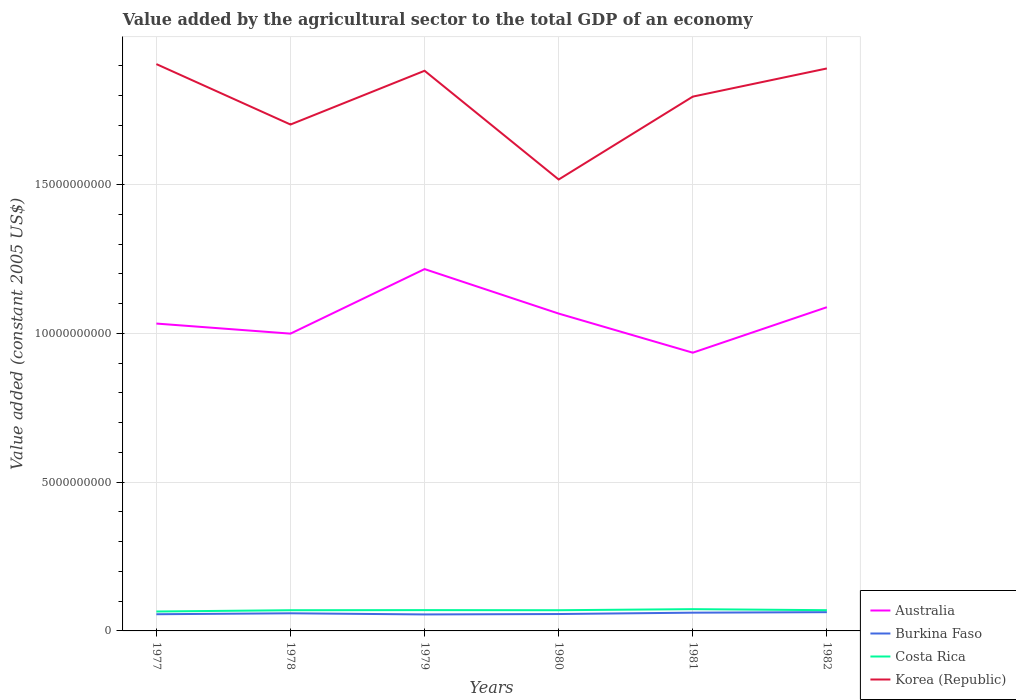Does the line corresponding to Korea (Republic) intersect with the line corresponding to Australia?
Keep it short and to the point. No. Across all years, what is the maximum value added by the agricultural sector in Korea (Republic)?
Give a very brief answer. 1.52e+1. In which year was the value added by the agricultural sector in Burkina Faso maximum?
Your response must be concise. 1979. What is the total value added by the agricultural sector in Costa Rica in the graph?
Your answer should be very brief. -3.55e+07. What is the difference between the highest and the second highest value added by the agricultural sector in Korea (Republic)?
Offer a terse response. 3.88e+09. Is the value added by the agricultural sector in Costa Rica strictly greater than the value added by the agricultural sector in Australia over the years?
Provide a short and direct response. Yes. How many lines are there?
Provide a succinct answer. 4. How many years are there in the graph?
Offer a very short reply. 6. Does the graph contain grids?
Make the answer very short. Yes. How many legend labels are there?
Provide a succinct answer. 4. How are the legend labels stacked?
Keep it short and to the point. Vertical. What is the title of the graph?
Offer a terse response. Value added by the agricultural sector to the total GDP of an economy. What is the label or title of the Y-axis?
Provide a succinct answer. Value added (constant 2005 US$). What is the Value added (constant 2005 US$) in Australia in 1977?
Give a very brief answer. 1.03e+1. What is the Value added (constant 2005 US$) in Burkina Faso in 1977?
Make the answer very short. 5.61e+08. What is the Value added (constant 2005 US$) of Costa Rica in 1977?
Your response must be concise. 6.53e+08. What is the Value added (constant 2005 US$) in Korea (Republic) in 1977?
Make the answer very short. 1.91e+1. What is the Value added (constant 2005 US$) in Australia in 1978?
Provide a short and direct response. 9.99e+09. What is the Value added (constant 2005 US$) of Burkina Faso in 1978?
Provide a short and direct response. 5.92e+08. What is the Value added (constant 2005 US$) of Costa Rica in 1978?
Provide a short and direct response. 6.96e+08. What is the Value added (constant 2005 US$) of Korea (Republic) in 1978?
Your answer should be compact. 1.70e+1. What is the Value added (constant 2005 US$) in Australia in 1979?
Keep it short and to the point. 1.22e+1. What is the Value added (constant 2005 US$) in Burkina Faso in 1979?
Give a very brief answer. 5.54e+08. What is the Value added (constant 2005 US$) in Costa Rica in 1979?
Ensure brevity in your answer.  7.00e+08. What is the Value added (constant 2005 US$) of Korea (Republic) in 1979?
Give a very brief answer. 1.88e+1. What is the Value added (constant 2005 US$) in Australia in 1980?
Offer a very short reply. 1.07e+1. What is the Value added (constant 2005 US$) in Burkina Faso in 1980?
Your answer should be compact. 5.68e+08. What is the Value added (constant 2005 US$) in Costa Rica in 1980?
Keep it short and to the point. 6.96e+08. What is the Value added (constant 2005 US$) in Korea (Republic) in 1980?
Make the answer very short. 1.52e+1. What is the Value added (constant 2005 US$) in Australia in 1981?
Give a very brief answer. 9.35e+09. What is the Value added (constant 2005 US$) of Burkina Faso in 1981?
Your answer should be compact. 6.14e+08. What is the Value added (constant 2005 US$) of Costa Rica in 1981?
Provide a succinct answer. 7.32e+08. What is the Value added (constant 2005 US$) in Korea (Republic) in 1981?
Give a very brief answer. 1.80e+1. What is the Value added (constant 2005 US$) of Australia in 1982?
Ensure brevity in your answer.  1.09e+1. What is the Value added (constant 2005 US$) in Burkina Faso in 1982?
Offer a very short reply. 6.31e+08. What is the Value added (constant 2005 US$) in Costa Rica in 1982?
Keep it short and to the point. 6.97e+08. What is the Value added (constant 2005 US$) of Korea (Republic) in 1982?
Ensure brevity in your answer.  1.89e+1. Across all years, what is the maximum Value added (constant 2005 US$) of Australia?
Offer a terse response. 1.22e+1. Across all years, what is the maximum Value added (constant 2005 US$) in Burkina Faso?
Provide a short and direct response. 6.31e+08. Across all years, what is the maximum Value added (constant 2005 US$) of Costa Rica?
Provide a short and direct response. 7.32e+08. Across all years, what is the maximum Value added (constant 2005 US$) of Korea (Republic)?
Ensure brevity in your answer.  1.91e+1. Across all years, what is the minimum Value added (constant 2005 US$) of Australia?
Keep it short and to the point. 9.35e+09. Across all years, what is the minimum Value added (constant 2005 US$) in Burkina Faso?
Your response must be concise. 5.54e+08. Across all years, what is the minimum Value added (constant 2005 US$) of Costa Rica?
Keep it short and to the point. 6.53e+08. Across all years, what is the minimum Value added (constant 2005 US$) in Korea (Republic)?
Offer a very short reply. 1.52e+1. What is the total Value added (constant 2005 US$) of Australia in the graph?
Ensure brevity in your answer.  6.34e+1. What is the total Value added (constant 2005 US$) of Burkina Faso in the graph?
Ensure brevity in your answer.  3.52e+09. What is the total Value added (constant 2005 US$) in Costa Rica in the graph?
Provide a succinct answer. 4.17e+09. What is the total Value added (constant 2005 US$) of Korea (Republic) in the graph?
Give a very brief answer. 1.07e+11. What is the difference between the Value added (constant 2005 US$) in Australia in 1977 and that in 1978?
Keep it short and to the point. 3.39e+08. What is the difference between the Value added (constant 2005 US$) in Burkina Faso in 1977 and that in 1978?
Your answer should be very brief. -3.14e+07. What is the difference between the Value added (constant 2005 US$) in Costa Rica in 1977 and that in 1978?
Your response must be concise. -4.31e+07. What is the difference between the Value added (constant 2005 US$) of Korea (Republic) in 1977 and that in 1978?
Make the answer very short. 2.03e+09. What is the difference between the Value added (constant 2005 US$) in Australia in 1977 and that in 1979?
Offer a terse response. -1.83e+09. What is the difference between the Value added (constant 2005 US$) of Burkina Faso in 1977 and that in 1979?
Make the answer very short. 6.73e+06. What is the difference between the Value added (constant 2005 US$) of Costa Rica in 1977 and that in 1979?
Provide a short and direct response. -4.66e+07. What is the difference between the Value added (constant 2005 US$) of Korea (Republic) in 1977 and that in 1979?
Offer a terse response. 2.25e+08. What is the difference between the Value added (constant 2005 US$) of Australia in 1977 and that in 1980?
Provide a short and direct response. -3.35e+08. What is the difference between the Value added (constant 2005 US$) in Burkina Faso in 1977 and that in 1980?
Your answer should be very brief. -6.97e+06. What is the difference between the Value added (constant 2005 US$) of Costa Rica in 1977 and that in 1980?
Your answer should be compact. -4.31e+07. What is the difference between the Value added (constant 2005 US$) in Korea (Republic) in 1977 and that in 1980?
Offer a very short reply. 3.88e+09. What is the difference between the Value added (constant 2005 US$) of Australia in 1977 and that in 1981?
Your response must be concise. 9.80e+08. What is the difference between the Value added (constant 2005 US$) of Burkina Faso in 1977 and that in 1981?
Keep it short and to the point. -5.28e+07. What is the difference between the Value added (constant 2005 US$) in Costa Rica in 1977 and that in 1981?
Your answer should be very brief. -7.85e+07. What is the difference between the Value added (constant 2005 US$) in Korea (Republic) in 1977 and that in 1981?
Provide a succinct answer. 1.09e+09. What is the difference between the Value added (constant 2005 US$) in Australia in 1977 and that in 1982?
Your response must be concise. -5.50e+08. What is the difference between the Value added (constant 2005 US$) in Burkina Faso in 1977 and that in 1982?
Offer a terse response. -6.99e+07. What is the difference between the Value added (constant 2005 US$) of Costa Rica in 1977 and that in 1982?
Your answer should be very brief. -4.41e+07. What is the difference between the Value added (constant 2005 US$) of Korea (Republic) in 1977 and that in 1982?
Your answer should be compact. 1.47e+08. What is the difference between the Value added (constant 2005 US$) in Australia in 1978 and that in 1979?
Offer a terse response. -2.17e+09. What is the difference between the Value added (constant 2005 US$) of Burkina Faso in 1978 and that in 1979?
Your answer should be compact. 3.82e+07. What is the difference between the Value added (constant 2005 US$) in Costa Rica in 1978 and that in 1979?
Provide a succinct answer. -3.45e+06. What is the difference between the Value added (constant 2005 US$) of Korea (Republic) in 1978 and that in 1979?
Offer a terse response. -1.81e+09. What is the difference between the Value added (constant 2005 US$) of Australia in 1978 and that in 1980?
Give a very brief answer. -6.74e+08. What is the difference between the Value added (constant 2005 US$) in Burkina Faso in 1978 and that in 1980?
Ensure brevity in your answer.  2.45e+07. What is the difference between the Value added (constant 2005 US$) in Costa Rica in 1978 and that in 1980?
Offer a terse response. 4.01e+04. What is the difference between the Value added (constant 2005 US$) of Korea (Republic) in 1978 and that in 1980?
Give a very brief answer. 1.85e+09. What is the difference between the Value added (constant 2005 US$) of Australia in 1978 and that in 1981?
Keep it short and to the point. 6.41e+08. What is the difference between the Value added (constant 2005 US$) of Burkina Faso in 1978 and that in 1981?
Ensure brevity in your answer.  -2.14e+07. What is the difference between the Value added (constant 2005 US$) in Costa Rica in 1978 and that in 1981?
Provide a short and direct response. -3.54e+07. What is the difference between the Value added (constant 2005 US$) of Korea (Republic) in 1978 and that in 1981?
Your answer should be very brief. -9.38e+08. What is the difference between the Value added (constant 2005 US$) of Australia in 1978 and that in 1982?
Make the answer very short. -8.89e+08. What is the difference between the Value added (constant 2005 US$) of Burkina Faso in 1978 and that in 1982?
Provide a succinct answer. -3.85e+07. What is the difference between the Value added (constant 2005 US$) in Costa Rica in 1978 and that in 1982?
Your answer should be very brief. -1.04e+06. What is the difference between the Value added (constant 2005 US$) of Korea (Republic) in 1978 and that in 1982?
Provide a short and direct response. -1.89e+09. What is the difference between the Value added (constant 2005 US$) in Australia in 1979 and that in 1980?
Provide a succinct answer. 1.50e+09. What is the difference between the Value added (constant 2005 US$) of Burkina Faso in 1979 and that in 1980?
Make the answer very short. -1.37e+07. What is the difference between the Value added (constant 2005 US$) of Costa Rica in 1979 and that in 1980?
Your response must be concise. 3.49e+06. What is the difference between the Value added (constant 2005 US$) of Korea (Republic) in 1979 and that in 1980?
Give a very brief answer. 3.66e+09. What is the difference between the Value added (constant 2005 US$) in Australia in 1979 and that in 1981?
Your answer should be compact. 2.81e+09. What is the difference between the Value added (constant 2005 US$) of Burkina Faso in 1979 and that in 1981?
Give a very brief answer. -5.96e+07. What is the difference between the Value added (constant 2005 US$) in Costa Rica in 1979 and that in 1981?
Your answer should be very brief. -3.20e+07. What is the difference between the Value added (constant 2005 US$) in Korea (Republic) in 1979 and that in 1981?
Offer a terse response. 8.69e+08. What is the difference between the Value added (constant 2005 US$) of Australia in 1979 and that in 1982?
Ensure brevity in your answer.  1.28e+09. What is the difference between the Value added (constant 2005 US$) of Burkina Faso in 1979 and that in 1982?
Your answer should be very brief. -7.67e+07. What is the difference between the Value added (constant 2005 US$) of Costa Rica in 1979 and that in 1982?
Make the answer very short. 2.41e+06. What is the difference between the Value added (constant 2005 US$) of Korea (Republic) in 1979 and that in 1982?
Provide a succinct answer. -7.82e+07. What is the difference between the Value added (constant 2005 US$) of Australia in 1980 and that in 1981?
Give a very brief answer. 1.32e+09. What is the difference between the Value added (constant 2005 US$) in Burkina Faso in 1980 and that in 1981?
Give a very brief answer. -4.59e+07. What is the difference between the Value added (constant 2005 US$) in Costa Rica in 1980 and that in 1981?
Make the answer very short. -3.55e+07. What is the difference between the Value added (constant 2005 US$) in Korea (Republic) in 1980 and that in 1981?
Your answer should be compact. -2.79e+09. What is the difference between the Value added (constant 2005 US$) in Australia in 1980 and that in 1982?
Your response must be concise. -2.15e+08. What is the difference between the Value added (constant 2005 US$) in Burkina Faso in 1980 and that in 1982?
Give a very brief answer. -6.30e+07. What is the difference between the Value added (constant 2005 US$) of Costa Rica in 1980 and that in 1982?
Your answer should be compact. -1.08e+06. What is the difference between the Value added (constant 2005 US$) in Korea (Republic) in 1980 and that in 1982?
Offer a terse response. -3.73e+09. What is the difference between the Value added (constant 2005 US$) in Australia in 1981 and that in 1982?
Provide a succinct answer. -1.53e+09. What is the difference between the Value added (constant 2005 US$) of Burkina Faso in 1981 and that in 1982?
Keep it short and to the point. -1.71e+07. What is the difference between the Value added (constant 2005 US$) in Costa Rica in 1981 and that in 1982?
Your answer should be very brief. 3.44e+07. What is the difference between the Value added (constant 2005 US$) in Korea (Republic) in 1981 and that in 1982?
Your answer should be compact. -9.47e+08. What is the difference between the Value added (constant 2005 US$) in Australia in 1977 and the Value added (constant 2005 US$) in Burkina Faso in 1978?
Offer a terse response. 9.74e+09. What is the difference between the Value added (constant 2005 US$) in Australia in 1977 and the Value added (constant 2005 US$) in Costa Rica in 1978?
Your answer should be compact. 9.64e+09. What is the difference between the Value added (constant 2005 US$) in Australia in 1977 and the Value added (constant 2005 US$) in Korea (Republic) in 1978?
Your answer should be very brief. -6.69e+09. What is the difference between the Value added (constant 2005 US$) of Burkina Faso in 1977 and the Value added (constant 2005 US$) of Costa Rica in 1978?
Provide a succinct answer. -1.35e+08. What is the difference between the Value added (constant 2005 US$) of Burkina Faso in 1977 and the Value added (constant 2005 US$) of Korea (Republic) in 1978?
Provide a succinct answer. -1.65e+1. What is the difference between the Value added (constant 2005 US$) in Costa Rica in 1977 and the Value added (constant 2005 US$) in Korea (Republic) in 1978?
Offer a terse response. -1.64e+1. What is the difference between the Value added (constant 2005 US$) of Australia in 1977 and the Value added (constant 2005 US$) of Burkina Faso in 1979?
Ensure brevity in your answer.  9.78e+09. What is the difference between the Value added (constant 2005 US$) in Australia in 1977 and the Value added (constant 2005 US$) in Costa Rica in 1979?
Your answer should be very brief. 9.63e+09. What is the difference between the Value added (constant 2005 US$) in Australia in 1977 and the Value added (constant 2005 US$) in Korea (Republic) in 1979?
Keep it short and to the point. -8.50e+09. What is the difference between the Value added (constant 2005 US$) of Burkina Faso in 1977 and the Value added (constant 2005 US$) of Costa Rica in 1979?
Ensure brevity in your answer.  -1.39e+08. What is the difference between the Value added (constant 2005 US$) of Burkina Faso in 1977 and the Value added (constant 2005 US$) of Korea (Republic) in 1979?
Give a very brief answer. -1.83e+1. What is the difference between the Value added (constant 2005 US$) in Costa Rica in 1977 and the Value added (constant 2005 US$) in Korea (Republic) in 1979?
Make the answer very short. -1.82e+1. What is the difference between the Value added (constant 2005 US$) of Australia in 1977 and the Value added (constant 2005 US$) of Burkina Faso in 1980?
Offer a terse response. 9.77e+09. What is the difference between the Value added (constant 2005 US$) of Australia in 1977 and the Value added (constant 2005 US$) of Costa Rica in 1980?
Offer a very short reply. 9.64e+09. What is the difference between the Value added (constant 2005 US$) in Australia in 1977 and the Value added (constant 2005 US$) in Korea (Republic) in 1980?
Your answer should be very brief. -4.84e+09. What is the difference between the Value added (constant 2005 US$) in Burkina Faso in 1977 and the Value added (constant 2005 US$) in Costa Rica in 1980?
Provide a short and direct response. -1.35e+08. What is the difference between the Value added (constant 2005 US$) in Burkina Faso in 1977 and the Value added (constant 2005 US$) in Korea (Republic) in 1980?
Your response must be concise. -1.46e+1. What is the difference between the Value added (constant 2005 US$) of Costa Rica in 1977 and the Value added (constant 2005 US$) of Korea (Republic) in 1980?
Offer a terse response. -1.45e+1. What is the difference between the Value added (constant 2005 US$) of Australia in 1977 and the Value added (constant 2005 US$) of Burkina Faso in 1981?
Provide a succinct answer. 9.72e+09. What is the difference between the Value added (constant 2005 US$) in Australia in 1977 and the Value added (constant 2005 US$) in Costa Rica in 1981?
Make the answer very short. 9.60e+09. What is the difference between the Value added (constant 2005 US$) of Australia in 1977 and the Value added (constant 2005 US$) of Korea (Republic) in 1981?
Give a very brief answer. -7.63e+09. What is the difference between the Value added (constant 2005 US$) of Burkina Faso in 1977 and the Value added (constant 2005 US$) of Costa Rica in 1981?
Give a very brief answer. -1.71e+08. What is the difference between the Value added (constant 2005 US$) in Burkina Faso in 1977 and the Value added (constant 2005 US$) in Korea (Republic) in 1981?
Keep it short and to the point. -1.74e+1. What is the difference between the Value added (constant 2005 US$) of Costa Rica in 1977 and the Value added (constant 2005 US$) of Korea (Republic) in 1981?
Offer a terse response. -1.73e+1. What is the difference between the Value added (constant 2005 US$) in Australia in 1977 and the Value added (constant 2005 US$) in Burkina Faso in 1982?
Keep it short and to the point. 9.70e+09. What is the difference between the Value added (constant 2005 US$) in Australia in 1977 and the Value added (constant 2005 US$) in Costa Rica in 1982?
Ensure brevity in your answer.  9.64e+09. What is the difference between the Value added (constant 2005 US$) of Australia in 1977 and the Value added (constant 2005 US$) of Korea (Republic) in 1982?
Offer a terse response. -8.58e+09. What is the difference between the Value added (constant 2005 US$) of Burkina Faso in 1977 and the Value added (constant 2005 US$) of Costa Rica in 1982?
Offer a very short reply. -1.36e+08. What is the difference between the Value added (constant 2005 US$) in Burkina Faso in 1977 and the Value added (constant 2005 US$) in Korea (Republic) in 1982?
Offer a terse response. -1.83e+1. What is the difference between the Value added (constant 2005 US$) in Costa Rica in 1977 and the Value added (constant 2005 US$) in Korea (Republic) in 1982?
Provide a succinct answer. -1.83e+1. What is the difference between the Value added (constant 2005 US$) of Australia in 1978 and the Value added (constant 2005 US$) of Burkina Faso in 1979?
Your response must be concise. 9.44e+09. What is the difference between the Value added (constant 2005 US$) in Australia in 1978 and the Value added (constant 2005 US$) in Costa Rica in 1979?
Keep it short and to the point. 9.30e+09. What is the difference between the Value added (constant 2005 US$) of Australia in 1978 and the Value added (constant 2005 US$) of Korea (Republic) in 1979?
Keep it short and to the point. -8.84e+09. What is the difference between the Value added (constant 2005 US$) in Burkina Faso in 1978 and the Value added (constant 2005 US$) in Costa Rica in 1979?
Give a very brief answer. -1.07e+08. What is the difference between the Value added (constant 2005 US$) in Burkina Faso in 1978 and the Value added (constant 2005 US$) in Korea (Republic) in 1979?
Provide a short and direct response. -1.82e+1. What is the difference between the Value added (constant 2005 US$) in Costa Rica in 1978 and the Value added (constant 2005 US$) in Korea (Republic) in 1979?
Your answer should be compact. -1.81e+1. What is the difference between the Value added (constant 2005 US$) of Australia in 1978 and the Value added (constant 2005 US$) of Burkina Faso in 1980?
Give a very brief answer. 9.43e+09. What is the difference between the Value added (constant 2005 US$) in Australia in 1978 and the Value added (constant 2005 US$) in Costa Rica in 1980?
Your response must be concise. 9.30e+09. What is the difference between the Value added (constant 2005 US$) of Australia in 1978 and the Value added (constant 2005 US$) of Korea (Republic) in 1980?
Your answer should be compact. -5.18e+09. What is the difference between the Value added (constant 2005 US$) of Burkina Faso in 1978 and the Value added (constant 2005 US$) of Costa Rica in 1980?
Offer a terse response. -1.04e+08. What is the difference between the Value added (constant 2005 US$) in Burkina Faso in 1978 and the Value added (constant 2005 US$) in Korea (Republic) in 1980?
Your answer should be compact. -1.46e+1. What is the difference between the Value added (constant 2005 US$) in Costa Rica in 1978 and the Value added (constant 2005 US$) in Korea (Republic) in 1980?
Your response must be concise. -1.45e+1. What is the difference between the Value added (constant 2005 US$) of Australia in 1978 and the Value added (constant 2005 US$) of Burkina Faso in 1981?
Offer a very short reply. 9.38e+09. What is the difference between the Value added (constant 2005 US$) of Australia in 1978 and the Value added (constant 2005 US$) of Costa Rica in 1981?
Keep it short and to the point. 9.26e+09. What is the difference between the Value added (constant 2005 US$) in Australia in 1978 and the Value added (constant 2005 US$) in Korea (Republic) in 1981?
Provide a succinct answer. -7.97e+09. What is the difference between the Value added (constant 2005 US$) in Burkina Faso in 1978 and the Value added (constant 2005 US$) in Costa Rica in 1981?
Ensure brevity in your answer.  -1.39e+08. What is the difference between the Value added (constant 2005 US$) in Burkina Faso in 1978 and the Value added (constant 2005 US$) in Korea (Republic) in 1981?
Give a very brief answer. -1.74e+1. What is the difference between the Value added (constant 2005 US$) of Costa Rica in 1978 and the Value added (constant 2005 US$) of Korea (Republic) in 1981?
Offer a terse response. -1.73e+1. What is the difference between the Value added (constant 2005 US$) in Australia in 1978 and the Value added (constant 2005 US$) in Burkina Faso in 1982?
Give a very brief answer. 9.36e+09. What is the difference between the Value added (constant 2005 US$) of Australia in 1978 and the Value added (constant 2005 US$) of Costa Rica in 1982?
Your response must be concise. 9.30e+09. What is the difference between the Value added (constant 2005 US$) of Australia in 1978 and the Value added (constant 2005 US$) of Korea (Republic) in 1982?
Keep it short and to the point. -8.92e+09. What is the difference between the Value added (constant 2005 US$) of Burkina Faso in 1978 and the Value added (constant 2005 US$) of Costa Rica in 1982?
Provide a short and direct response. -1.05e+08. What is the difference between the Value added (constant 2005 US$) in Burkina Faso in 1978 and the Value added (constant 2005 US$) in Korea (Republic) in 1982?
Your answer should be very brief. -1.83e+1. What is the difference between the Value added (constant 2005 US$) in Costa Rica in 1978 and the Value added (constant 2005 US$) in Korea (Republic) in 1982?
Ensure brevity in your answer.  -1.82e+1. What is the difference between the Value added (constant 2005 US$) of Australia in 1979 and the Value added (constant 2005 US$) of Burkina Faso in 1980?
Ensure brevity in your answer.  1.16e+1. What is the difference between the Value added (constant 2005 US$) in Australia in 1979 and the Value added (constant 2005 US$) in Costa Rica in 1980?
Provide a succinct answer. 1.15e+1. What is the difference between the Value added (constant 2005 US$) of Australia in 1979 and the Value added (constant 2005 US$) of Korea (Republic) in 1980?
Your response must be concise. -3.01e+09. What is the difference between the Value added (constant 2005 US$) of Burkina Faso in 1979 and the Value added (constant 2005 US$) of Costa Rica in 1980?
Keep it short and to the point. -1.42e+08. What is the difference between the Value added (constant 2005 US$) in Burkina Faso in 1979 and the Value added (constant 2005 US$) in Korea (Republic) in 1980?
Provide a short and direct response. -1.46e+1. What is the difference between the Value added (constant 2005 US$) of Costa Rica in 1979 and the Value added (constant 2005 US$) of Korea (Republic) in 1980?
Offer a very short reply. -1.45e+1. What is the difference between the Value added (constant 2005 US$) of Australia in 1979 and the Value added (constant 2005 US$) of Burkina Faso in 1981?
Provide a short and direct response. 1.16e+1. What is the difference between the Value added (constant 2005 US$) in Australia in 1979 and the Value added (constant 2005 US$) in Costa Rica in 1981?
Your response must be concise. 1.14e+1. What is the difference between the Value added (constant 2005 US$) in Australia in 1979 and the Value added (constant 2005 US$) in Korea (Republic) in 1981?
Your response must be concise. -5.80e+09. What is the difference between the Value added (constant 2005 US$) of Burkina Faso in 1979 and the Value added (constant 2005 US$) of Costa Rica in 1981?
Your answer should be very brief. -1.77e+08. What is the difference between the Value added (constant 2005 US$) of Burkina Faso in 1979 and the Value added (constant 2005 US$) of Korea (Republic) in 1981?
Your answer should be very brief. -1.74e+1. What is the difference between the Value added (constant 2005 US$) in Costa Rica in 1979 and the Value added (constant 2005 US$) in Korea (Republic) in 1981?
Your answer should be very brief. -1.73e+1. What is the difference between the Value added (constant 2005 US$) in Australia in 1979 and the Value added (constant 2005 US$) in Burkina Faso in 1982?
Offer a very short reply. 1.15e+1. What is the difference between the Value added (constant 2005 US$) in Australia in 1979 and the Value added (constant 2005 US$) in Costa Rica in 1982?
Keep it short and to the point. 1.15e+1. What is the difference between the Value added (constant 2005 US$) in Australia in 1979 and the Value added (constant 2005 US$) in Korea (Republic) in 1982?
Give a very brief answer. -6.75e+09. What is the difference between the Value added (constant 2005 US$) in Burkina Faso in 1979 and the Value added (constant 2005 US$) in Costa Rica in 1982?
Keep it short and to the point. -1.43e+08. What is the difference between the Value added (constant 2005 US$) of Burkina Faso in 1979 and the Value added (constant 2005 US$) of Korea (Republic) in 1982?
Your answer should be very brief. -1.84e+1. What is the difference between the Value added (constant 2005 US$) in Costa Rica in 1979 and the Value added (constant 2005 US$) in Korea (Republic) in 1982?
Ensure brevity in your answer.  -1.82e+1. What is the difference between the Value added (constant 2005 US$) in Australia in 1980 and the Value added (constant 2005 US$) in Burkina Faso in 1981?
Give a very brief answer. 1.01e+1. What is the difference between the Value added (constant 2005 US$) of Australia in 1980 and the Value added (constant 2005 US$) of Costa Rica in 1981?
Keep it short and to the point. 9.94e+09. What is the difference between the Value added (constant 2005 US$) of Australia in 1980 and the Value added (constant 2005 US$) of Korea (Republic) in 1981?
Provide a short and direct response. -7.29e+09. What is the difference between the Value added (constant 2005 US$) in Burkina Faso in 1980 and the Value added (constant 2005 US$) in Costa Rica in 1981?
Provide a succinct answer. -1.64e+08. What is the difference between the Value added (constant 2005 US$) of Burkina Faso in 1980 and the Value added (constant 2005 US$) of Korea (Republic) in 1981?
Provide a succinct answer. -1.74e+1. What is the difference between the Value added (constant 2005 US$) of Costa Rica in 1980 and the Value added (constant 2005 US$) of Korea (Republic) in 1981?
Ensure brevity in your answer.  -1.73e+1. What is the difference between the Value added (constant 2005 US$) in Australia in 1980 and the Value added (constant 2005 US$) in Burkina Faso in 1982?
Keep it short and to the point. 1.00e+1. What is the difference between the Value added (constant 2005 US$) in Australia in 1980 and the Value added (constant 2005 US$) in Costa Rica in 1982?
Keep it short and to the point. 9.97e+09. What is the difference between the Value added (constant 2005 US$) of Australia in 1980 and the Value added (constant 2005 US$) of Korea (Republic) in 1982?
Your answer should be compact. -8.24e+09. What is the difference between the Value added (constant 2005 US$) of Burkina Faso in 1980 and the Value added (constant 2005 US$) of Costa Rica in 1982?
Provide a succinct answer. -1.29e+08. What is the difference between the Value added (constant 2005 US$) of Burkina Faso in 1980 and the Value added (constant 2005 US$) of Korea (Republic) in 1982?
Your answer should be compact. -1.83e+1. What is the difference between the Value added (constant 2005 US$) in Costa Rica in 1980 and the Value added (constant 2005 US$) in Korea (Republic) in 1982?
Ensure brevity in your answer.  -1.82e+1. What is the difference between the Value added (constant 2005 US$) in Australia in 1981 and the Value added (constant 2005 US$) in Burkina Faso in 1982?
Give a very brief answer. 8.72e+09. What is the difference between the Value added (constant 2005 US$) of Australia in 1981 and the Value added (constant 2005 US$) of Costa Rica in 1982?
Provide a short and direct response. 8.66e+09. What is the difference between the Value added (constant 2005 US$) of Australia in 1981 and the Value added (constant 2005 US$) of Korea (Republic) in 1982?
Offer a terse response. -9.56e+09. What is the difference between the Value added (constant 2005 US$) in Burkina Faso in 1981 and the Value added (constant 2005 US$) in Costa Rica in 1982?
Your answer should be compact. -8.34e+07. What is the difference between the Value added (constant 2005 US$) of Burkina Faso in 1981 and the Value added (constant 2005 US$) of Korea (Republic) in 1982?
Give a very brief answer. -1.83e+1. What is the difference between the Value added (constant 2005 US$) of Costa Rica in 1981 and the Value added (constant 2005 US$) of Korea (Republic) in 1982?
Your answer should be very brief. -1.82e+1. What is the average Value added (constant 2005 US$) of Australia per year?
Offer a very short reply. 1.06e+1. What is the average Value added (constant 2005 US$) of Burkina Faso per year?
Your answer should be very brief. 5.87e+08. What is the average Value added (constant 2005 US$) in Costa Rica per year?
Give a very brief answer. 6.96e+08. What is the average Value added (constant 2005 US$) of Korea (Republic) per year?
Offer a terse response. 1.78e+1. In the year 1977, what is the difference between the Value added (constant 2005 US$) in Australia and Value added (constant 2005 US$) in Burkina Faso?
Offer a terse response. 9.77e+09. In the year 1977, what is the difference between the Value added (constant 2005 US$) in Australia and Value added (constant 2005 US$) in Costa Rica?
Your answer should be compact. 9.68e+09. In the year 1977, what is the difference between the Value added (constant 2005 US$) in Australia and Value added (constant 2005 US$) in Korea (Republic)?
Ensure brevity in your answer.  -8.72e+09. In the year 1977, what is the difference between the Value added (constant 2005 US$) in Burkina Faso and Value added (constant 2005 US$) in Costa Rica?
Offer a terse response. -9.21e+07. In the year 1977, what is the difference between the Value added (constant 2005 US$) in Burkina Faso and Value added (constant 2005 US$) in Korea (Republic)?
Ensure brevity in your answer.  -1.85e+1. In the year 1977, what is the difference between the Value added (constant 2005 US$) of Costa Rica and Value added (constant 2005 US$) of Korea (Republic)?
Give a very brief answer. -1.84e+1. In the year 1978, what is the difference between the Value added (constant 2005 US$) in Australia and Value added (constant 2005 US$) in Burkina Faso?
Your answer should be very brief. 9.40e+09. In the year 1978, what is the difference between the Value added (constant 2005 US$) in Australia and Value added (constant 2005 US$) in Costa Rica?
Ensure brevity in your answer.  9.30e+09. In the year 1978, what is the difference between the Value added (constant 2005 US$) of Australia and Value added (constant 2005 US$) of Korea (Republic)?
Offer a terse response. -7.03e+09. In the year 1978, what is the difference between the Value added (constant 2005 US$) of Burkina Faso and Value added (constant 2005 US$) of Costa Rica?
Offer a very short reply. -1.04e+08. In the year 1978, what is the difference between the Value added (constant 2005 US$) of Burkina Faso and Value added (constant 2005 US$) of Korea (Republic)?
Make the answer very short. -1.64e+1. In the year 1978, what is the difference between the Value added (constant 2005 US$) of Costa Rica and Value added (constant 2005 US$) of Korea (Republic)?
Keep it short and to the point. -1.63e+1. In the year 1979, what is the difference between the Value added (constant 2005 US$) in Australia and Value added (constant 2005 US$) in Burkina Faso?
Provide a succinct answer. 1.16e+1. In the year 1979, what is the difference between the Value added (constant 2005 US$) in Australia and Value added (constant 2005 US$) in Costa Rica?
Your response must be concise. 1.15e+1. In the year 1979, what is the difference between the Value added (constant 2005 US$) in Australia and Value added (constant 2005 US$) in Korea (Republic)?
Make the answer very short. -6.67e+09. In the year 1979, what is the difference between the Value added (constant 2005 US$) in Burkina Faso and Value added (constant 2005 US$) in Costa Rica?
Your response must be concise. -1.45e+08. In the year 1979, what is the difference between the Value added (constant 2005 US$) of Burkina Faso and Value added (constant 2005 US$) of Korea (Republic)?
Provide a succinct answer. -1.83e+1. In the year 1979, what is the difference between the Value added (constant 2005 US$) of Costa Rica and Value added (constant 2005 US$) of Korea (Republic)?
Keep it short and to the point. -1.81e+1. In the year 1980, what is the difference between the Value added (constant 2005 US$) in Australia and Value added (constant 2005 US$) in Burkina Faso?
Offer a very short reply. 1.01e+1. In the year 1980, what is the difference between the Value added (constant 2005 US$) of Australia and Value added (constant 2005 US$) of Costa Rica?
Offer a very short reply. 9.97e+09. In the year 1980, what is the difference between the Value added (constant 2005 US$) of Australia and Value added (constant 2005 US$) of Korea (Republic)?
Your answer should be compact. -4.51e+09. In the year 1980, what is the difference between the Value added (constant 2005 US$) of Burkina Faso and Value added (constant 2005 US$) of Costa Rica?
Offer a very short reply. -1.28e+08. In the year 1980, what is the difference between the Value added (constant 2005 US$) in Burkina Faso and Value added (constant 2005 US$) in Korea (Republic)?
Offer a very short reply. -1.46e+1. In the year 1980, what is the difference between the Value added (constant 2005 US$) in Costa Rica and Value added (constant 2005 US$) in Korea (Republic)?
Make the answer very short. -1.45e+1. In the year 1981, what is the difference between the Value added (constant 2005 US$) in Australia and Value added (constant 2005 US$) in Burkina Faso?
Your response must be concise. 8.74e+09. In the year 1981, what is the difference between the Value added (constant 2005 US$) of Australia and Value added (constant 2005 US$) of Costa Rica?
Your answer should be very brief. 8.62e+09. In the year 1981, what is the difference between the Value added (constant 2005 US$) of Australia and Value added (constant 2005 US$) of Korea (Republic)?
Provide a short and direct response. -8.61e+09. In the year 1981, what is the difference between the Value added (constant 2005 US$) of Burkina Faso and Value added (constant 2005 US$) of Costa Rica?
Your answer should be very brief. -1.18e+08. In the year 1981, what is the difference between the Value added (constant 2005 US$) in Burkina Faso and Value added (constant 2005 US$) in Korea (Republic)?
Ensure brevity in your answer.  -1.73e+1. In the year 1981, what is the difference between the Value added (constant 2005 US$) in Costa Rica and Value added (constant 2005 US$) in Korea (Republic)?
Your answer should be compact. -1.72e+1. In the year 1982, what is the difference between the Value added (constant 2005 US$) of Australia and Value added (constant 2005 US$) of Burkina Faso?
Your answer should be very brief. 1.03e+1. In the year 1982, what is the difference between the Value added (constant 2005 US$) in Australia and Value added (constant 2005 US$) in Costa Rica?
Offer a terse response. 1.02e+1. In the year 1982, what is the difference between the Value added (constant 2005 US$) in Australia and Value added (constant 2005 US$) in Korea (Republic)?
Your answer should be compact. -8.03e+09. In the year 1982, what is the difference between the Value added (constant 2005 US$) of Burkina Faso and Value added (constant 2005 US$) of Costa Rica?
Make the answer very short. -6.63e+07. In the year 1982, what is the difference between the Value added (constant 2005 US$) of Burkina Faso and Value added (constant 2005 US$) of Korea (Republic)?
Keep it short and to the point. -1.83e+1. In the year 1982, what is the difference between the Value added (constant 2005 US$) of Costa Rica and Value added (constant 2005 US$) of Korea (Republic)?
Your response must be concise. -1.82e+1. What is the ratio of the Value added (constant 2005 US$) of Australia in 1977 to that in 1978?
Provide a short and direct response. 1.03. What is the ratio of the Value added (constant 2005 US$) of Burkina Faso in 1977 to that in 1978?
Provide a succinct answer. 0.95. What is the ratio of the Value added (constant 2005 US$) in Costa Rica in 1977 to that in 1978?
Your answer should be compact. 0.94. What is the ratio of the Value added (constant 2005 US$) in Korea (Republic) in 1977 to that in 1978?
Make the answer very short. 1.12. What is the ratio of the Value added (constant 2005 US$) of Australia in 1977 to that in 1979?
Offer a terse response. 0.85. What is the ratio of the Value added (constant 2005 US$) of Burkina Faso in 1977 to that in 1979?
Give a very brief answer. 1.01. What is the ratio of the Value added (constant 2005 US$) of Costa Rica in 1977 to that in 1979?
Offer a terse response. 0.93. What is the ratio of the Value added (constant 2005 US$) of Korea (Republic) in 1977 to that in 1979?
Make the answer very short. 1.01. What is the ratio of the Value added (constant 2005 US$) in Australia in 1977 to that in 1980?
Ensure brevity in your answer.  0.97. What is the ratio of the Value added (constant 2005 US$) of Burkina Faso in 1977 to that in 1980?
Give a very brief answer. 0.99. What is the ratio of the Value added (constant 2005 US$) in Costa Rica in 1977 to that in 1980?
Offer a terse response. 0.94. What is the ratio of the Value added (constant 2005 US$) in Korea (Republic) in 1977 to that in 1980?
Provide a succinct answer. 1.26. What is the ratio of the Value added (constant 2005 US$) of Australia in 1977 to that in 1981?
Your answer should be compact. 1.1. What is the ratio of the Value added (constant 2005 US$) of Burkina Faso in 1977 to that in 1981?
Keep it short and to the point. 0.91. What is the ratio of the Value added (constant 2005 US$) of Costa Rica in 1977 to that in 1981?
Provide a short and direct response. 0.89. What is the ratio of the Value added (constant 2005 US$) of Korea (Republic) in 1977 to that in 1981?
Your answer should be very brief. 1.06. What is the ratio of the Value added (constant 2005 US$) of Australia in 1977 to that in 1982?
Offer a very short reply. 0.95. What is the ratio of the Value added (constant 2005 US$) in Burkina Faso in 1977 to that in 1982?
Make the answer very short. 0.89. What is the ratio of the Value added (constant 2005 US$) of Costa Rica in 1977 to that in 1982?
Keep it short and to the point. 0.94. What is the ratio of the Value added (constant 2005 US$) in Australia in 1978 to that in 1979?
Provide a succinct answer. 0.82. What is the ratio of the Value added (constant 2005 US$) of Burkina Faso in 1978 to that in 1979?
Your answer should be compact. 1.07. What is the ratio of the Value added (constant 2005 US$) of Costa Rica in 1978 to that in 1979?
Your response must be concise. 1. What is the ratio of the Value added (constant 2005 US$) of Korea (Republic) in 1978 to that in 1979?
Give a very brief answer. 0.9. What is the ratio of the Value added (constant 2005 US$) of Australia in 1978 to that in 1980?
Provide a short and direct response. 0.94. What is the ratio of the Value added (constant 2005 US$) in Burkina Faso in 1978 to that in 1980?
Offer a terse response. 1.04. What is the ratio of the Value added (constant 2005 US$) of Korea (Republic) in 1978 to that in 1980?
Ensure brevity in your answer.  1.12. What is the ratio of the Value added (constant 2005 US$) of Australia in 1978 to that in 1981?
Offer a very short reply. 1.07. What is the ratio of the Value added (constant 2005 US$) of Burkina Faso in 1978 to that in 1981?
Provide a short and direct response. 0.97. What is the ratio of the Value added (constant 2005 US$) in Costa Rica in 1978 to that in 1981?
Keep it short and to the point. 0.95. What is the ratio of the Value added (constant 2005 US$) in Korea (Republic) in 1978 to that in 1981?
Give a very brief answer. 0.95. What is the ratio of the Value added (constant 2005 US$) in Australia in 1978 to that in 1982?
Offer a terse response. 0.92. What is the ratio of the Value added (constant 2005 US$) of Burkina Faso in 1978 to that in 1982?
Provide a short and direct response. 0.94. What is the ratio of the Value added (constant 2005 US$) of Korea (Republic) in 1978 to that in 1982?
Your answer should be very brief. 0.9. What is the ratio of the Value added (constant 2005 US$) in Australia in 1979 to that in 1980?
Your response must be concise. 1.14. What is the ratio of the Value added (constant 2005 US$) in Burkina Faso in 1979 to that in 1980?
Give a very brief answer. 0.98. What is the ratio of the Value added (constant 2005 US$) in Korea (Republic) in 1979 to that in 1980?
Offer a terse response. 1.24. What is the ratio of the Value added (constant 2005 US$) in Australia in 1979 to that in 1981?
Provide a short and direct response. 1.3. What is the ratio of the Value added (constant 2005 US$) in Burkina Faso in 1979 to that in 1981?
Give a very brief answer. 0.9. What is the ratio of the Value added (constant 2005 US$) in Costa Rica in 1979 to that in 1981?
Your response must be concise. 0.96. What is the ratio of the Value added (constant 2005 US$) in Korea (Republic) in 1979 to that in 1981?
Provide a succinct answer. 1.05. What is the ratio of the Value added (constant 2005 US$) in Australia in 1979 to that in 1982?
Give a very brief answer. 1.12. What is the ratio of the Value added (constant 2005 US$) of Burkina Faso in 1979 to that in 1982?
Provide a succinct answer. 0.88. What is the ratio of the Value added (constant 2005 US$) in Australia in 1980 to that in 1981?
Provide a succinct answer. 1.14. What is the ratio of the Value added (constant 2005 US$) of Burkina Faso in 1980 to that in 1981?
Offer a very short reply. 0.93. What is the ratio of the Value added (constant 2005 US$) in Costa Rica in 1980 to that in 1981?
Offer a very short reply. 0.95. What is the ratio of the Value added (constant 2005 US$) of Korea (Republic) in 1980 to that in 1981?
Provide a succinct answer. 0.84. What is the ratio of the Value added (constant 2005 US$) of Australia in 1980 to that in 1982?
Keep it short and to the point. 0.98. What is the ratio of the Value added (constant 2005 US$) in Burkina Faso in 1980 to that in 1982?
Give a very brief answer. 0.9. What is the ratio of the Value added (constant 2005 US$) of Costa Rica in 1980 to that in 1982?
Offer a very short reply. 1. What is the ratio of the Value added (constant 2005 US$) in Korea (Republic) in 1980 to that in 1982?
Ensure brevity in your answer.  0.8. What is the ratio of the Value added (constant 2005 US$) in Australia in 1981 to that in 1982?
Provide a succinct answer. 0.86. What is the ratio of the Value added (constant 2005 US$) in Burkina Faso in 1981 to that in 1982?
Your response must be concise. 0.97. What is the ratio of the Value added (constant 2005 US$) of Costa Rica in 1981 to that in 1982?
Offer a terse response. 1.05. What is the ratio of the Value added (constant 2005 US$) of Korea (Republic) in 1981 to that in 1982?
Your response must be concise. 0.95. What is the difference between the highest and the second highest Value added (constant 2005 US$) of Australia?
Ensure brevity in your answer.  1.28e+09. What is the difference between the highest and the second highest Value added (constant 2005 US$) of Burkina Faso?
Offer a very short reply. 1.71e+07. What is the difference between the highest and the second highest Value added (constant 2005 US$) in Costa Rica?
Offer a terse response. 3.20e+07. What is the difference between the highest and the second highest Value added (constant 2005 US$) in Korea (Republic)?
Ensure brevity in your answer.  1.47e+08. What is the difference between the highest and the lowest Value added (constant 2005 US$) of Australia?
Keep it short and to the point. 2.81e+09. What is the difference between the highest and the lowest Value added (constant 2005 US$) in Burkina Faso?
Keep it short and to the point. 7.67e+07. What is the difference between the highest and the lowest Value added (constant 2005 US$) of Costa Rica?
Offer a terse response. 7.85e+07. What is the difference between the highest and the lowest Value added (constant 2005 US$) of Korea (Republic)?
Your answer should be very brief. 3.88e+09. 